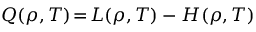<formula> <loc_0><loc_0><loc_500><loc_500>Q \, \left ( \rho , T \right ) \, = \, L \, \left ( \rho , T \right ) - H \, \left ( \rho , T \right )</formula> 